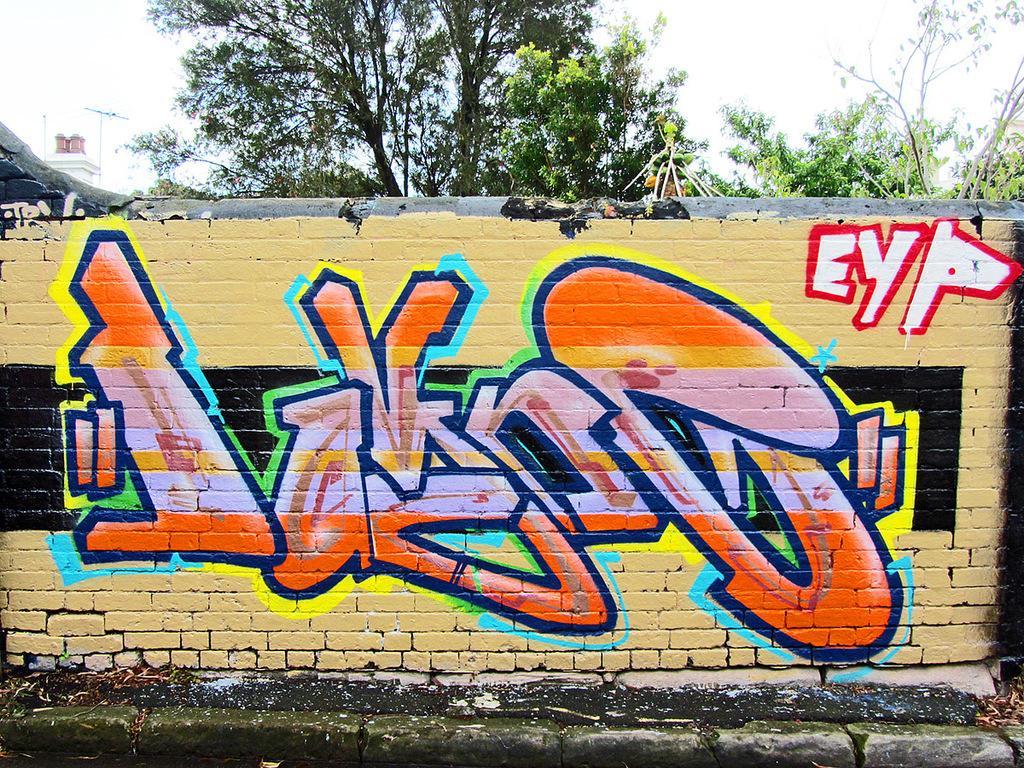Can you describe this image briefly? In this image we can see painting on the wall. In the background we can see branches, sky, and an object. 